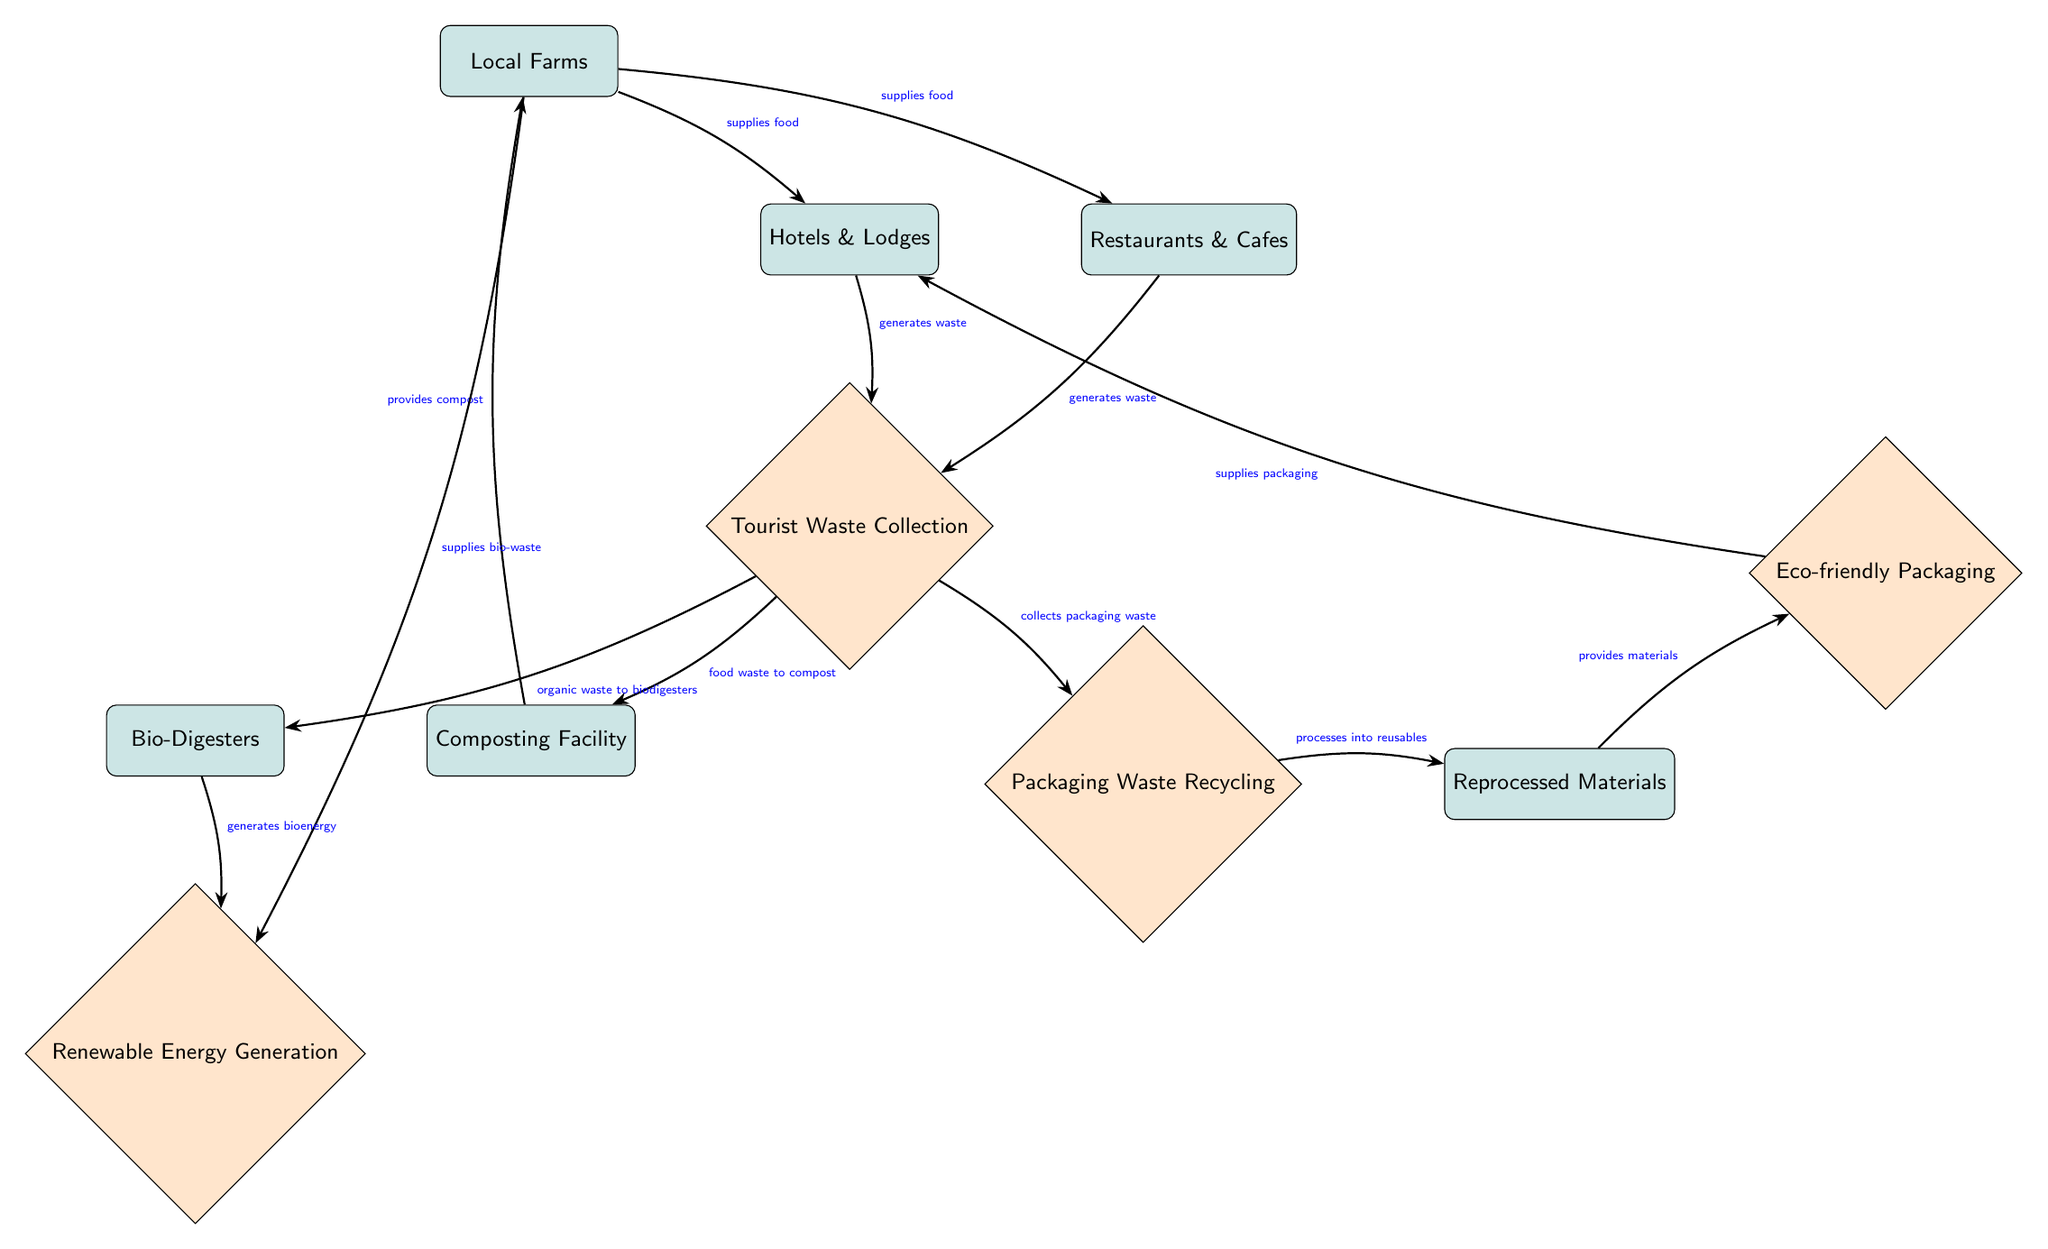What's the total number of nodes in the diagram? The diagram includes the following nodes: Hotels & Lodges, Restaurants & Cafes, Tourist Waste Collection, Composting Facility, Bio-Digesters, Local Farms, Packaging Waste Recycling, Reprocessed Materials, Eco-friendly Packaging, Renewable Energy Generation. Counting these, the total number of nodes is 10.
Answer: 10 What waste do hotels and restaurants generate? Both the Hotels & Lodges and Restaurants & Cafes nodes are connected to the Tourist Waste Collection node, indicating that they generate waste that is collected there.
Answer: waste How does food waste from Tourist Waste Collection reach Local Farms? The food waste is first directed towards the Composting Facility after being collected by Tourist Waste Collection. The Composting Facility then provides compost to Local Farms.
Answer: compost Which node receives bio-waste from Local Farms? The diagram shows that Local Farms supply bio-waste to the Bio-Digesters, making it the node that receives bio-waste.
Answer: Bio-Digesters What type of energy is generated from Bio-Digesters? The flow in the diagram indicates that Bio-Digesters generate bioenergy, which is directed towards Renewable Energy Generation.
Answer: bioenergy How do Hotels & Lodges acquire packaging materials? The Hotels & Lodges connect to Eco-friendly Packaging, which receives its materials from the Reprocessed Materials node, which is fed by Packaging Waste Recycling. Therefore, the Hotels & Lodges acquire their packaging materials through this chain of nodes.
Answer: Eco-friendly Packaging Which entity supplies food to both Hotels & Lodges and Restaurants & Cafes? The Local Farms supply food to both the Hotels & Lodges and Restaurants & Cafes as indicated by the two separate arrows coming from the Farms node towards both of these entities.
Answer: Local Farms How many processes are represented in the diagram? The processes indicated in the diagram include: Tourist Waste Collection, Composting Facility, Packaging Waste Recycling, Eco-friendly Packaging, and Renewable Energy Generation. Counting these reveals that there are 5 processes.
Answer: 5 What is the direction of flow from Tourist Waste Collection after waste is generated? After waste is collected by Tourist Waste Collection, it flows towards two main processes: Composting Facility and Packaging Waste Recycling. Therefore, the direction of flow shows it branches into two routes from the Tourist Waste Collection.
Answer: Composting Facility and Packaging Waste Recycling 